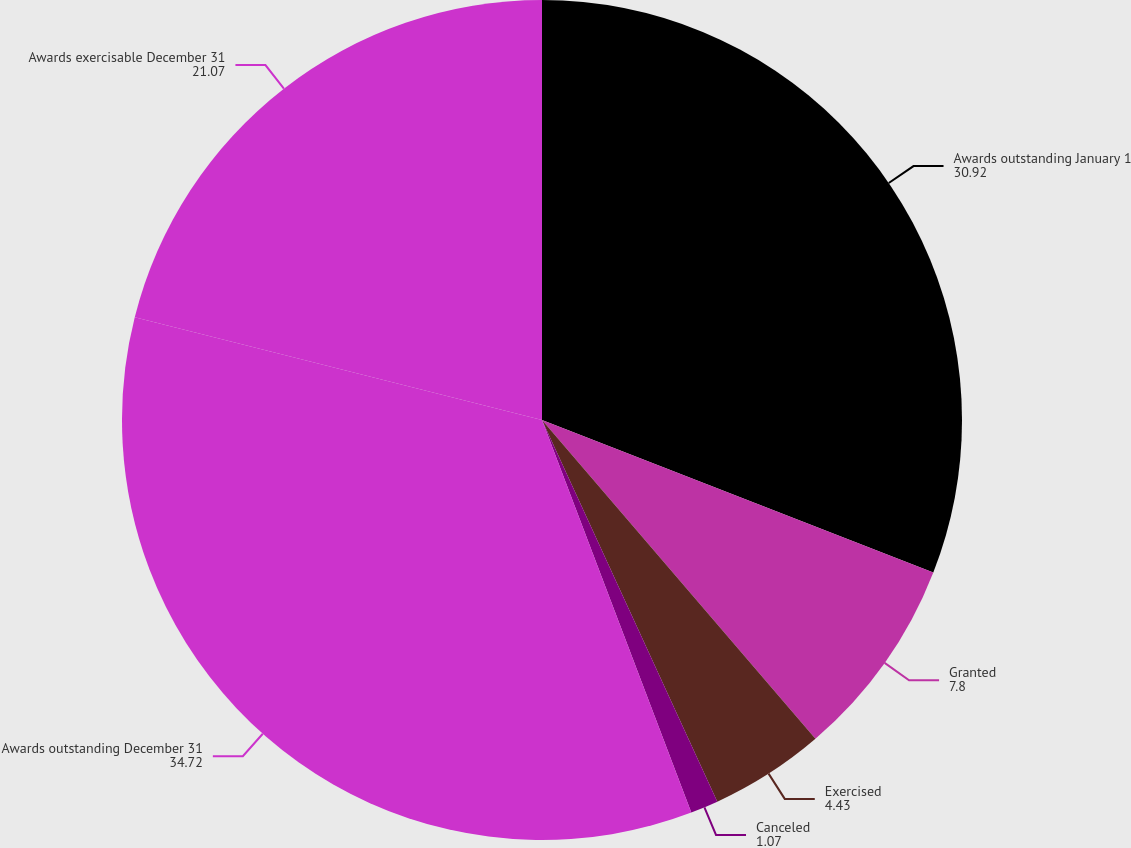Convert chart to OTSL. <chart><loc_0><loc_0><loc_500><loc_500><pie_chart><fcel>Awards outstanding January 1<fcel>Granted<fcel>Exercised<fcel>Canceled<fcel>Awards outstanding December 31<fcel>Awards exercisable December 31<nl><fcel>30.92%<fcel>7.8%<fcel>4.43%<fcel>1.07%<fcel>34.72%<fcel>21.07%<nl></chart> 